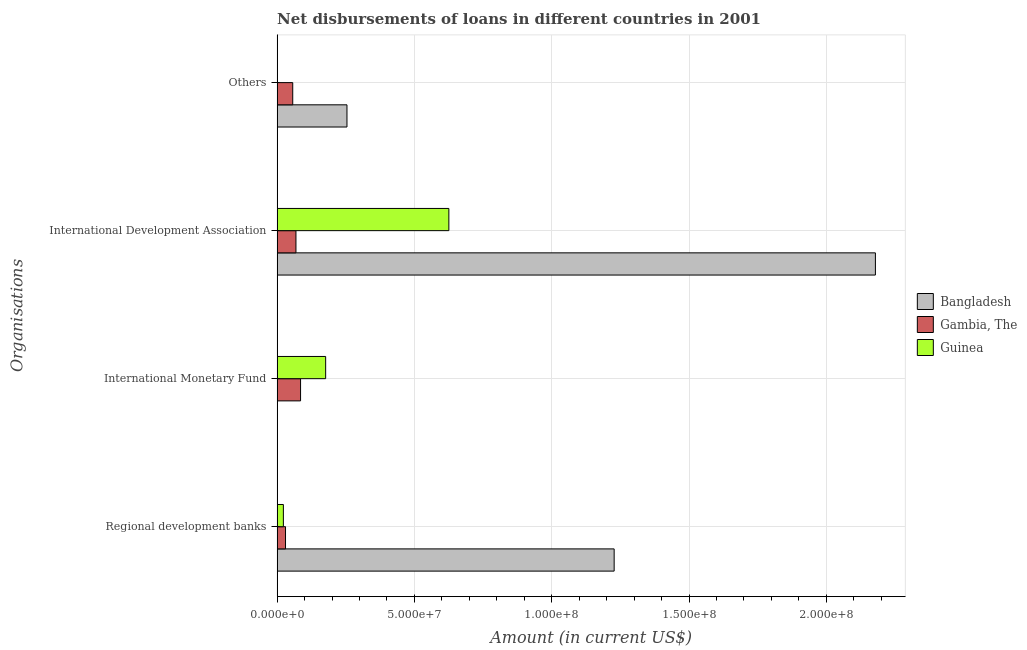How many groups of bars are there?
Ensure brevity in your answer.  4. Are the number of bars per tick equal to the number of legend labels?
Make the answer very short. No. What is the label of the 2nd group of bars from the top?
Keep it short and to the point. International Development Association. What is the amount of loan disimbursed by international monetary fund in Gambia, The?
Provide a succinct answer. 8.54e+06. Across all countries, what is the maximum amount of loan disimbursed by regional development banks?
Make the answer very short. 1.23e+08. Across all countries, what is the minimum amount of loan disimbursed by international development association?
Offer a very short reply. 6.86e+06. In which country was the amount of loan disimbursed by other organisations maximum?
Your response must be concise. Bangladesh. What is the total amount of loan disimbursed by regional development banks in the graph?
Keep it short and to the point. 1.28e+08. What is the difference between the amount of loan disimbursed by international development association in Guinea and that in Gambia, The?
Offer a terse response. 5.57e+07. What is the difference between the amount of loan disimbursed by international development association in Guinea and the amount of loan disimbursed by international monetary fund in Gambia, The?
Make the answer very short. 5.40e+07. What is the average amount of loan disimbursed by other organisations per country?
Your answer should be compact. 1.04e+07. What is the difference between the amount of loan disimbursed by international monetary fund and amount of loan disimbursed by other organisations in Gambia, The?
Give a very brief answer. 2.85e+06. In how many countries, is the amount of loan disimbursed by regional development banks greater than 160000000 US$?
Make the answer very short. 0. What is the ratio of the amount of loan disimbursed by regional development banks in Guinea to that in Gambia, The?
Ensure brevity in your answer.  0.74. Is the amount of loan disimbursed by other organisations in Bangladesh less than that in Gambia, The?
Your answer should be compact. No. Is the difference between the amount of loan disimbursed by international development association in Gambia, The and Bangladesh greater than the difference between the amount of loan disimbursed by other organisations in Gambia, The and Bangladesh?
Your response must be concise. No. What is the difference between the highest and the second highest amount of loan disimbursed by regional development banks?
Your answer should be very brief. 1.20e+08. What is the difference between the highest and the lowest amount of loan disimbursed by regional development banks?
Provide a succinct answer. 1.20e+08. Is it the case that in every country, the sum of the amount of loan disimbursed by regional development banks and amount of loan disimbursed by other organisations is greater than the sum of amount of loan disimbursed by international development association and amount of loan disimbursed by international monetary fund?
Keep it short and to the point. No. Is it the case that in every country, the sum of the amount of loan disimbursed by regional development banks and amount of loan disimbursed by international monetary fund is greater than the amount of loan disimbursed by international development association?
Give a very brief answer. No. How many bars are there?
Your answer should be compact. 10. Are all the bars in the graph horizontal?
Ensure brevity in your answer.  Yes. What is the difference between two consecutive major ticks on the X-axis?
Ensure brevity in your answer.  5.00e+07. Does the graph contain any zero values?
Offer a very short reply. Yes. What is the title of the graph?
Offer a terse response. Net disbursements of loans in different countries in 2001. What is the label or title of the X-axis?
Provide a succinct answer. Amount (in current US$). What is the label or title of the Y-axis?
Provide a short and direct response. Organisations. What is the Amount (in current US$) of Bangladesh in Regional development banks?
Your response must be concise. 1.23e+08. What is the Amount (in current US$) in Gambia, The in Regional development banks?
Your answer should be very brief. 3.06e+06. What is the Amount (in current US$) of Guinea in Regional development banks?
Ensure brevity in your answer.  2.28e+06. What is the Amount (in current US$) of Gambia, The in International Monetary Fund?
Keep it short and to the point. 8.54e+06. What is the Amount (in current US$) in Guinea in International Monetary Fund?
Keep it short and to the point. 1.77e+07. What is the Amount (in current US$) in Bangladesh in International Development Association?
Offer a very short reply. 2.18e+08. What is the Amount (in current US$) in Gambia, The in International Development Association?
Give a very brief answer. 6.86e+06. What is the Amount (in current US$) of Guinea in International Development Association?
Make the answer very short. 6.25e+07. What is the Amount (in current US$) in Bangladesh in Others?
Your answer should be very brief. 2.54e+07. What is the Amount (in current US$) of Gambia, The in Others?
Ensure brevity in your answer.  5.69e+06. Across all Organisations, what is the maximum Amount (in current US$) of Bangladesh?
Provide a short and direct response. 2.18e+08. Across all Organisations, what is the maximum Amount (in current US$) in Gambia, The?
Your answer should be compact. 8.54e+06. Across all Organisations, what is the maximum Amount (in current US$) of Guinea?
Keep it short and to the point. 6.25e+07. Across all Organisations, what is the minimum Amount (in current US$) of Bangladesh?
Keep it short and to the point. 0. Across all Organisations, what is the minimum Amount (in current US$) in Gambia, The?
Make the answer very short. 3.06e+06. What is the total Amount (in current US$) in Bangladesh in the graph?
Offer a very short reply. 3.66e+08. What is the total Amount (in current US$) of Gambia, The in the graph?
Give a very brief answer. 2.41e+07. What is the total Amount (in current US$) of Guinea in the graph?
Provide a short and direct response. 8.25e+07. What is the difference between the Amount (in current US$) in Gambia, The in Regional development banks and that in International Monetary Fund?
Give a very brief answer. -5.48e+06. What is the difference between the Amount (in current US$) in Guinea in Regional development banks and that in International Monetary Fund?
Provide a succinct answer. -1.54e+07. What is the difference between the Amount (in current US$) in Bangladesh in Regional development banks and that in International Development Association?
Keep it short and to the point. -9.51e+07. What is the difference between the Amount (in current US$) in Gambia, The in Regional development banks and that in International Development Association?
Provide a succinct answer. -3.80e+06. What is the difference between the Amount (in current US$) in Guinea in Regional development banks and that in International Development Association?
Offer a very short reply. -6.03e+07. What is the difference between the Amount (in current US$) in Bangladesh in Regional development banks and that in Others?
Make the answer very short. 9.73e+07. What is the difference between the Amount (in current US$) of Gambia, The in Regional development banks and that in Others?
Offer a very short reply. -2.63e+06. What is the difference between the Amount (in current US$) of Gambia, The in International Monetary Fund and that in International Development Association?
Your response must be concise. 1.68e+06. What is the difference between the Amount (in current US$) in Guinea in International Monetary Fund and that in International Development Association?
Make the answer very short. -4.49e+07. What is the difference between the Amount (in current US$) in Gambia, The in International Monetary Fund and that in Others?
Provide a short and direct response. 2.85e+06. What is the difference between the Amount (in current US$) of Bangladesh in International Development Association and that in Others?
Offer a very short reply. 1.92e+08. What is the difference between the Amount (in current US$) of Gambia, The in International Development Association and that in Others?
Make the answer very short. 1.17e+06. What is the difference between the Amount (in current US$) in Bangladesh in Regional development banks and the Amount (in current US$) in Gambia, The in International Monetary Fund?
Your answer should be compact. 1.14e+08. What is the difference between the Amount (in current US$) in Bangladesh in Regional development banks and the Amount (in current US$) in Guinea in International Monetary Fund?
Make the answer very short. 1.05e+08. What is the difference between the Amount (in current US$) of Gambia, The in Regional development banks and the Amount (in current US$) of Guinea in International Monetary Fund?
Keep it short and to the point. -1.46e+07. What is the difference between the Amount (in current US$) in Bangladesh in Regional development banks and the Amount (in current US$) in Gambia, The in International Development Association?
Offer a very short reply. 1.16e+08. What is the difference between the Amount (in current US$) of Bangladesh in Regional development banks and the Amount (in current US$) of Guinea in International Development Association?
Provide a succinct answer. 6.02e+07. What is the difference between the Amount (in current US$) in Gambia, The in Regional development banks and the Amount (in current US$) in Guinea in International Development Association?
Your answer should be very brief. -5.95e+07. What is the difference between the Amount (in current US$) of Bangladesh in Regional development banks and the Amount (in current US$) of Gambia, The in Others?
Offer a terse response. 1.17e+08. What is the difference between the Amount (in current US$) in Gambia, The in International Monetary Fund and the Amount (in current US$) in Guinea in International Development Association?
Provide a short and direct response. -5.40e+07. What is the difference between the Amount (in current US$) of Bangladesh in International Development Association and the Amount (in current US$) of Gambia, The in Others?
Provide a short and direct response. 2.12e+08. What is the average Amount (in current US$) of Bangladesh per Organisations?
Give a very brief answer. 9.15e+07. What is the average Amount (in current US$) in Gambia, The per Organisations?
Ensure brevity in your answer.  6.03e+06. What is the average Amount (in current US$) in Guinea per Organisations?
Offer a very short reply. 2.06e+07. What is the difference between the Amount (in current US$) of Bangladesh and Amount (in current US$) of Gambia, The in Regional development banks?
Offer a very short reply. 1.20e+08. What is the difference between the Amount (in current US$) in Bangladesh and Amount (in current US$) in Guinea in Regional development banks?
Provide a short and direct response. 1.20e+08. What is the difference between the Amount (in current US$) in Gambia, The and Amount (in current US$) in Guinea in Regional development banks?
Give a very brief answer. 7.80e+05. What is the difference between the Amount (in current US$) in Gambia, The and Amount (in current US$) in Guinea in International Monetary Fund?
Provide a short and direct response. -9.14e+06. What is the difference between the Amount (in current US$) in Bangladesh and Amount (in current US$) in Gambia, The in International Development Association?
Offer a terse response. 2.11e+08. What is the difference between the Amount (in current US$) in Bangladesh and Amount (in current US$) in Guinea in International Development Association?
Give a very brief answer. 1.55e+08. What is the difference between the Amount (in current US$) in Gambia, The and Amount (in current US$) in Guinea in International Development Association?
Make the answer very short. -5.57e+07. What is the difference between the Amount (in current US$) of Bangladesh and Amount (in current US$) of Gambia, The in Others?
Give a very brief answer. 1.98e+07. What is the ratio of the Amount (in current US$) in Gambia, The in Regional development banks to that in International Monetary Fund?
Ensure brevity in your answer.  0.36. What is the ratio of the Amount (in current US$) of Guinea in Regional development banks to that in International Monetary Fund?
Your response must be concise. 0.13. What is the ratio of the Amount (in current US$) in Bangladesh in Regional development banks to that in International Development Association?
Give a very brief answer. 0.56. What is the ratio of the Amount (in current US$) of Gambia, The in Regional development banks to that in International Development Association?
Ensure brevity in your answer.  0.45. What is the ratio of the Amount (in current US$) in Guinea in Regional development banks to that in International Development Association?
Your answer should be compact. 0.04. What is the ratio of the Amount (in current US$) of Bangladesh in Regional development banks to that in Others?
Your answer should be very brief. 4.83. What is the ratio of the Amount (in current US$) of Gambia, The in Regional development banks to that in Others?
Keep it short and to the point. 0.54. What is the ratio of the Amount (in current US$) in Gambia, The in International Monetary Fund to that in International Development Association?
Provide a short and direct response. 1.24. What is the ratio of the Amount (in current US$) in Guinea in International Monetary Fund to that in International Development Association?
Provide a short and direct response. 0.28. What is the ratio of the Amount (in current US$) of Gambia, The in International Monetary Fund to that in Others?
Your response must be concise. 1.5. What is the ratio of the Amount (in current US$) of Bangladesh in International Development Association to that in Others?
Ensure brevity in your answer.  8.57. What is the ratio of the Amount (in current US$) in Gambia, The in International Development Association to that in Others?
Keep it short and to the point. 1.21. What is the difference between the highest and the second highest Amount (in current US$) of Bangladesh?
Your answer should be compact. 9.51e+07. What is the difference between the highest and the second highest Amount (in current US$) in Gambia, The?
Provide a short and direct response. 1.68e+06. What is the difference between the highest and the second highest Amount (in current US$) in Guinea?
Your answer should be compact. 4.49e+07. What is the difference between the highest and the lowest Amount (in current US$) in Bangladesh?
Your answer should be very brief. 2.18e+08. What is the difference between the highest and the lowest Amount (in current US$) in Gambia, The?
Give a very brief answer. 5.48e+06. What is the difference between the highest and the lowest Amount (in current US$) in Guinea?
Keep it short and to the point. 6.25e+07. 